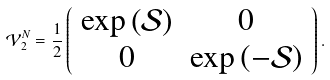<formula> <loc_0><loc_0><loc_500><loc_500>\mathcal { V } ^ { N } _ { 2 } = \frac { 1 } { 2 } \left ( \begin{array} { c c } \exp \left ( \mathcal { S } \right ) & 0 \\ 0 & \exp \left ( - \mathcal { S } \right ) \end{array} \right ) .</formula> 